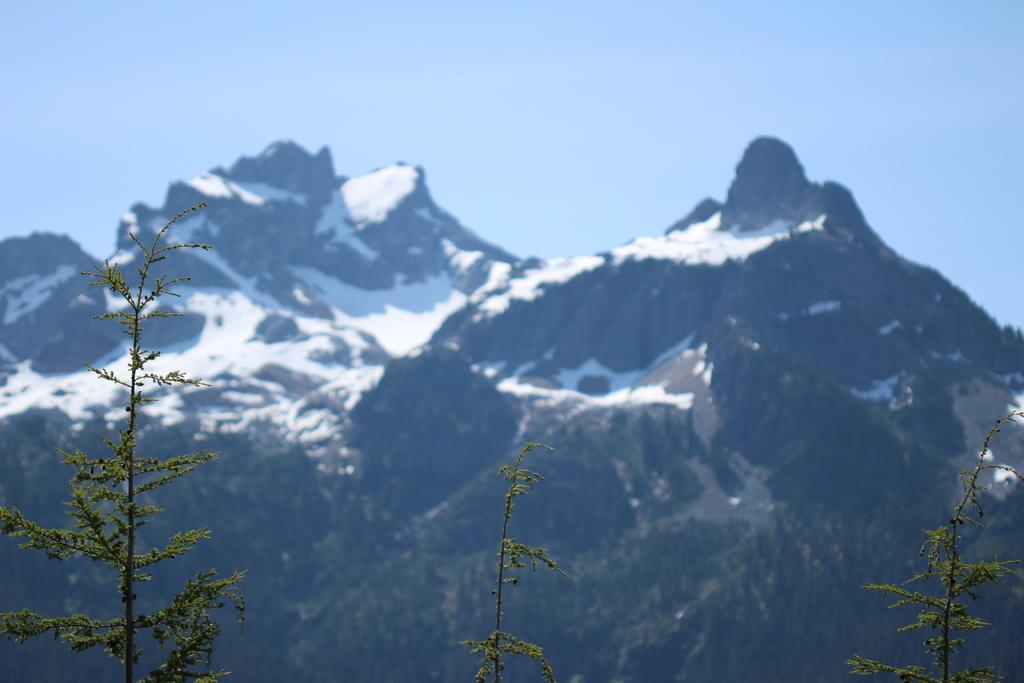Describe this image in one or two sentences. This picture shows mountains with snow and we see trees and a blue sky. 